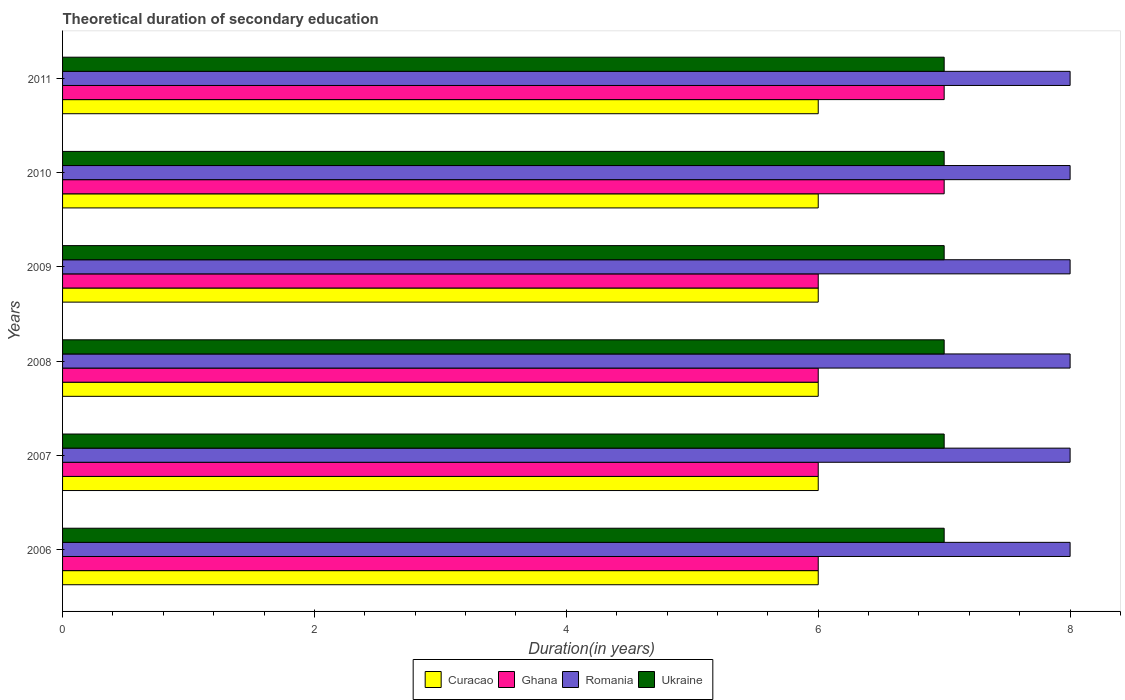How many different coloured bars are there?
Provide a succinct answer. 4. How many bars are there on the 1st tick from the bottom?
Your answer should be very brief. 4. What is the label of the 3rd group of bars from the top?
Your answer should be compact. 2009. In how many cases, is the number of bars for a given year not equal to the number of legend labels?
Provide a succinct answer. 0. What is the total theoretical duration of secondary education in Ukraine in 2008?
Make the answer very short. 7. Across all years, what is the maximum total theoretical duration of secondary education in Ukraine?
Ensure brevity in your answer.  7. Across all years, what is the minimum total theoretical duration of secondary education in Ghana?
Offer a very short reply. 6. What is the total total theoretical duration of secondary education in Ukraine in the graph?
Provide a short and direct response. 42. What is the difference between the total theoretical duration of secondary education in Ghana in 2009 and that in 2011?
Make the answer very short. -1. What is the difference between the total theoretical duration of secondary education in Curacao in 2010 and the total theoretical duration of secondary education in Romania in 2006?
Provide a succinct answer. -2. In how many years, is the total theoretical duration of secondary education in Ghana greater than 2.4 years?
Provide a short and direct response. 6. What is the ratio of the total theoretical duration of secondary education in Ukraine in 2007 to that in 2009?
Give a very brief answer. 1. Is the total theoretical duration of secondary education in Ghana in 2007 less than that in 2008?
Your response must be concise. No. What is the difference between the highest and the second highest total theoretical duration of secondary education in Ghana?
Offer a terse response. 0. What is the difference between the highest and the lowest total theoretical duration of secondary education in Ghana?
Your response must be concise. 1. Is the sum of the total theoretical duration of secondary education in Curacao in 2007 and 2010 greater than the maximum total theoretical duration of secondary education in Ghana across all years?
Keep it short and to the point. Yes. Is it the case that in every year, the sum of the total theoretical duration of secondary education in Ghana and total theoretical duration of secondary education in Ukraine is greater than the sum of total theoretical duration of secondary education in Romania and total theoretical duration of secondary education in Curacao?
Ensure brevity in your answer.  Yes. What does the 2nd bar from the top in 2007 represents?
Offer a very short reply. Romania. What does the 4th bar from the bottom in 2010 represents?
Provide a short and direct response. Ukraine. Is it the case that in every year, the sum of the total theoretical duration of secondary education in Curacao and total theoretical duration of secondary education in Romania is greater than the total theoretical duration of secondary education in Ghana?
Your answer should be very brief. Yes. Are all the bars in the graph horizontal?
Provide a succinct answer. Yes. How many years are there in the graph?
Offer a very short reply. 6. Does the graph contain any zero values?
Offer a very short reply. No. How many legend labels are there?
Your answer should be very brief. 4. How are the legend labels stacked?
Your answer should be compact. Horizontal. What is the title of the graph?
Your answer should be compact. Theoretical duration of secondary education. Does "Bahamas" appear as one of the legend labels in the graph?
Make the answer very short. No. What is the label or title of the X-axis?
Ensure brevity in your answer.  Duration(in years). What is the label or title of the Y-axis?
Give a very brief answer. Years. What is the Duration(in years) of Romania in 2006?
Give a very brief answer. 8. What is the Duration(in years) in Curacao in 2007?
Your answer should be very brief. 6. What is the Duration(in years) in Ghana in 2007?
Make the answer very short. 6. What is the Duration(in years) in Ghana in 2008?
Keep it short and to the point. 6. What is the Duration(in years) of Ukraine in 2008?
Your answer should be compact. 7. What is the Duration(in years) of Curacao in 2009?
Offer a very short reply. 6. What is the Duration(in years) in Romania in 2009?
Give a very brief answer. 8. What is the Duration(in years) in Romania in 2010?
Provide a succinct answer. 8. What is the Duration(in years) of Ukraine in 2010?
Give a very brief answer. 7. What is the Duration(in years) of Ghana in 2011?
Make the answer very short. 7. What is the Duration(in years) in Ukraine in 2011?
Give a very brief answer. 7. Across all years, what is the maximum Duration(in years) of Curacao?
Keep it short and to the point. 6. Across all years, what is the maximum Duration(in years) in Ghana?
Your answer should be compact. 7. Across all years, what is the minimum Duration(in years) of Curacao?
Make the answer very short. 6. Across all years, what is the minimum Duration(in years) in Romania?
Your answer should be compact. 8. What is the total Duration(in years) in Curacao in the graph?
Provide a short and direct response. 36. What is the total Duration(in years) of Ghana in the graph?
Provide a short and direct response. 38. What is the total Duration(in years) of Romania in the graph?
Provide a succinct answer. 48. What is the total Duration(in years) in Ukraine in the graph?
Your answer should be compact. 42. What is the difference between the Duration(in years) in Curacao in 2006 and that in 2007?
Offer a very short reply. 0. What is the difference between the Duration(in years) in Ghana in 2006 and that in 2007?
Your answer should be compact. 0. What is the difference between the Duration(in years) in Curacao in 2006 and that in 2008?
Give a very brief answer. 0. What is the difference between the Duration(in years) of Ghana in 2006 and that in 2008?
Make the answer very short. 0. What is the difference between the Duration(in years) in Romania in 2006 and that in 2008?
Offer a very short reply. 0. What is the difference between the Duration(in years) in Ukraine in 2006 and that in 2008?
Provide a short and direct response. 0. What is the difference between the Duration(in years) in Curacao in 2006 and that in 2009?
Give a very brief answer. 0. What is the difference between the Duration(in years) in Ghana in 2006 and that in 2009?
Offer a very short reply. 0. What is the difference between the Duration(in years) in Romania in 2006 and that in 2009?
Ensure brevity in your answer.  0. What is the difference between the Duration(in years) in Ukraine in 2006 and that in 2009?
Make the answer very short. 0. What is the difference between the Duration(in years) of Curacao in 2006 and that in 2010?
Give a very brief answer. 0. What is the difference between the Duration(in years) in Romania in 2006 and that in 2010?
Your answer should be compact. 0. What is the difference between the Duration(in years) in Curacao in 2007 and that in 2008?
Keep it short and to the point. 0. What is the difference between the Duration(in years) in Ghana in 2007 and that in 2008?
Ensure brevity in your answer.  0. What is the difference between the Duration(in years) of Ukraine in 2007 and that in 2008?
Your answer should be compact. 0. What is the difference between the Duration(in years) of Curacao in 2007 and that in 2009?
Provide a short and direct response. 0. What is the difference between the Duration(in years) of Curacao in 2007 and that in 2010?
Your answer should be compact. 0. What is the difference between the Duration(in years) in Romania in 2007 and that in 2010?
Give a very brief answer. 0. What is the difference between the Duration(in years) in Ghana in 2007 and that in 2011?
Provide a succinct answer. -1. What is the difference between the Duration(in years) of Ukraine in 2007 and that in 2011?
Offer a very short reply. 0. What is the difference between the Duration(in years) in Curacao in 2008 and that in 2009?
Your answer should be very brief. 0. What is the difference between the Duration(in years) in Ukraine in 2008 and that in 2009?
Offer a very short reply. 0. What is the difference between the Duration(in years) in Curacao in 2008 and that in 2010?
Offer a terse response. 0. What is the difference between the Duration(in years) of Ukraine in 2008 and that in 2010?
Your response must be concise. 0. What is the difference between the Duration(in years) in Ghana in 2009 and that in 2010?
Offer a very short reply. -1. What is the difference between the Duration(in years) of Romania in 2009 and that in 2010?
Your answer should be compact. 0. What is the difference between the Duration(in years) in Ghana in 2009 and that in 2011?
Give a very brief answer. -1. What is the difference between the Duration(in years) in Ukraine in 2009 and that in 2011?
Offer a terse response. 0. What is the difference between the Duration(in years) in Ghana in 2010 and that in 2011?
Provide a succinct answer. 0. What is the difference between the Duration(in years) of Curacao in 2006 and the Duration(in years) of Ukraine in 2007?
Provide a succinct answer. -1. What is the difference between the Duration(in years) of Ghana in 2006 and the Duration(in years) of Ukraine in 2007?
Provide a short and direct response. -1. What is the difference between the Duration(in years) in Curacao in 2006 and the Duration(in years) in Ukraine in 2008?
Provide a succinct answer. -1. What is the difference between the Duration(in years) in Ghana in 2006 and the Duration(in years) in Ukraine in 2008?
Ensure brevity in your answer.  -1. What is the difference between the Duration(in years) of Romania in 2006 and the Duration(in years) of Ukraine in 2008?
Give a very brief answer. 1. What is the difference between the Duration(in years) of Curacao in 2006 and the Duration(in years) of Romania in 2009?
Give a very brief answer. -2. What is the difference between the Duration(in years) of Romania in 2006 and the Duration(in years) of Ukraine in 2009?
Offer a terse response. 1. What is the difference between the Duration(in years) of Curacao in 2006 and the Duration(in years) of Ghana in 2010?
Your answer should be very brief. -1. What is the difference between the Duration(in years) of Curacao in 2006 and the Duration(in years) of Ukraine in 2010?
Provide a succinct answer. -1. What is the difference between the Duration(in years) of Ghana in 2006 and the Duration(in years) of Ukraine in 2010?
Your response must be concise. -1. What is the difference between the Duration(in years) in Curacao in 2006 and the Duration(in years) in Romania in 2011?
Your answer should be very brief. -2. What is the difference between the Duration(in years) of Romania in 2006 and the Duration(in years) of Ukraine in 2011?
Keep it short and to the point. 1. What is the difference between the Duration(in years) in Curacao in 2007 and the Duration(in years) in Romania in 2008?
Offer a terse response. -2. What is the difference between the Duration(in years) in Ghana in 2007 and the Duration(in years) in Ukraine in 2008?
Give a very brief answer. -1. What is the difference between the Duration(in years) in Romania in 2007 and the Duration(in years) in Ukraine in 2008?
Give a very brief answer. 1. What is the difference between the Duration(in years) in Curacao in 2007 and the Duration(in years) in Ghana in 2009?
Make the answer very short. 0. What is the difference between the Duration(in years) in Curacao in 2007 and the Duration(in years) in Ukraine in 2009?
Provide a short and direct response. -1. What is the difference between the Duration(in years) in Ghana in 2007 and the Duration(in years) in Romania in 2009?
Give a very brief answer. -2. What is the difference between the Duration(in years) of Ghana in 2007 and the Duration(in years) of Ukraine in 2009?
Your answer should be compact. -1. What is the difference between the Duration(in years) of Curacao in 2007 and the Duration(in years) of Ghana in 2010?
Your response must be concise. -1. What is the difference between the Duration(in years) of Curacao in 2007 and the Duration(in years) of Romania in 2010?
Provide a succinct answer. -2. What is the difference between the Duration(in years) in Ghana in 2007 and the Duration(in years) in Ukraine in 2010?
Make the answer very short. -1. What is the difference between the Duration(in years) of Romania in 2007 and the Duration(in years) of Ukraine in 2010?
Provide a succinct answer. 1. What is the difference between the Duration(in years) of Curacao in 2007 and the Duration(in years) of Ghana in 2011?
Keep it short and to the point. -1. What is the difference between the Duration(in years) in Ghana in 2007 and the Duration(in years) in Ukraine in 2011?
Make the answer very short. -1. What is the difference between the Duration(in years) of Romania in 2007 and the Duration(in years) of Ukraine in 2011?
Keep it short and to the point. 1. What is the difference between the Duration(in years) of Curacao in 2008 and the Duration(in years) of Romania in 2009?
Provide a short and direct response. -2. What is the difference between the Duration(in years) of Ghana in 2008 and the Duration(in years) of Romania in 2009?
Provide a short and direct response. -2. What is the difference between the Duration(in years) in Romania in 2008 and the Duration(in years) in Ukraine in 2009?
Your answer should be very brief. 1. What is the difference between the Duration(in years) of Curacao in 2008 and the Duration(in years) of Romania in 2010?
Your answer should be compact. -2. What is the difference between the Duration(in years) of Curacao in 2008 and the Duration(in years) of Ukraine in 2010?
Provide a short and direct response. -1. What is the difference between the Duration(in years) in Ghana in 2008 and the Duration(in years) in Ukraine in 2010?
Keep it short and to the point. -1. What is the difference between the Duration(in years) in Curacao in 2008 and the Duration(in years) in Romania in 2011?
Offer a very short reply. -2. What is the difference between the Duration(in years) of Ghana in 2008 and the Duration(in years) of Romania in 2011?
Your response must be concise. -2. What is the difference between the Duration(in years) in Romania in 2008 and the Duration(in years) in Ukraine in 2011?
Give a very brief answer. 1. What is the difference between the Duration(in years) of Curacao in 2009 and the Duration(in years) of Ghana in 2010?
Provide a succinct answer. -1. What is the difference between the Duration(in years) in Ghana in 2009 and the Duration(in years) in Romania in 2010?
Your answer should be compact. -2. What is the difference between the Duration(in years) in Ghana in 2009 and the Duration(in years) in Ukraine in 2010?
Offer a very short reply. -1. What is the difference between the Duration(in years) of Romania in 2009 and the Duration(in years) of Ukraine in 2010?
Provide a succinct answer. 1. What is the difference between the Duration(in years) of Curacao in 2009 and the Duration(in years) of Ukraine in 2011?
Your answer should be very brief. -1. What is the difference between the Duration(in years) in Ghana in 2009 and the Duration(in years) in Ukraine in 2011?
Offer a very short reply. -1. What is the difference between the Duration(in years) of Ghana in 2010 and the Duration(in years) of Ukraine in 2011?
Ensure brevity in your answer.  0. What is the average Duration(in years) of Curacao per year?
Your answer should be compact. 6. What is the average Duration(in years) in Ghana per year?
Your response must be concise. 6.33. In the year 2006, what is the difference between the Duration(in years) of Curacao and Duration(in years) of Ghana?
Your answer should be very brief. 0. In the year 2006, what is the difference between the Duration(in years) of Ghana and Duration(in years) of Romania?
Provide a succinct answer. -2. In the year 2006, what is the difference between the Duration(in years) in Romania and Duration(in years) in Ukraine?
Offer a very short reply. 1. In the year 2007, what is the difference between the Duration(in years) in Curacao and Duration(in years) in Romania?
Offer a terse response. -2. In the year 2007, what is the difference between the Duration(in years) in Curacao and Duration(in years) in Ukraine?
Ensure brevity in your answer.  -1. In the year 2007, what is the difference between the Duration(in years) in Ghana and Duration(in years) in Romania?
Provide a succinct answer. -2. In the year 2007, what is the difference between the Duration(in years) in Ghana and Duration(in years) in Ukraine?
Offer a very short reply. -1. In the year 2007, what is the difference between the Duration(in years) in Romania and Duration(in years) in Ukraine?
Keep it short and to the point. 1. In the year 2008, what is the difference between the Duration(in years) in Curacao and Duration(in years) in Romania?
Your answer should be very brief. -2. In the year 2008, what is the difference between the Duration(in years) in Curacao and Duration(in years) in Ukraine?
Your answer should be compact. -1. In the year 2008, what is the difference between the Duration(in years) of Ghana and Duration(in years) of Romania?
Offer a very short reply. -2. In the year 2008, what is the difference between the Duration(in years) of Ghana and Duration(in years) of Ukraine?
Keep it short and to the point. -1. In the year 2008, what is the difference between the Duration(in years) in Romania and Duration(in years) in Ukraine?
Keep it short and to the point. 1. In the year 2009, what is the difference between the Duration(in years) in Romania and Duration(in years) in Ukraine?
Your answer should be compact. 1. In the year 2010, what is the difference between the Duration(in years) of Curacao and Duration(in years) of Ghana?
Give a very brief answer. -1. In the year 2010, what is the difference between the Duration(in years) of Ghana and Duration(in years) of Ukraine?
Make the answer very short. 0. In the year 2010, what is the difference between the Duration(in years) in Romania and Duration(in years) in Ukraine?
Make the answer very short. 1. In the year 2011, what is the difference between the Duration(in years) of Curacao and Duration(in years) of Ukraine?
Provide a succinct answer. -1. In the year 2011, what is the difference between the Duration(in years) in Ghana and Duration(in years) in Romania?
Give a very brief answer. -1. In the year 2011, what is the difference between the Duration(in years) in Ghana and Duration(in years) in Ukraine?
Your answer should be compact. 0. In the year 2011, what is the difference between the Duration(in years) in Romania and Duration(in years) in Ukraine?
Your answer should be very brief. 1. What is the ratio of the Duration(in years) in Ghana in 2006 to that in 2007?
Offer a very short reply. 1. What is the ratio of the Duration(in years) in Romania in 2006 to that in 2007?
Offer a terse response. 1. What is the ratio of the Duration(in years) in Ukraine in 2006 to that in 2007?
Give a very brief answer. 1. What is the ratio of the Duration(in years) of Ghana in 2006 to that in 2008?
Your answer should be compact. 1. What is the ratio of the Duration(in years) of Ghana in 2006 to that in 2009?
Offer a very short reply. 1. What is the ratio of the Duration(in years) in Ghana in 2006 to that in 2010?
Keep it short and to the point. 0.86. What is the ratio of the Duration(in years) of Ukraine in 2006 to that in 2010?
Offer a terse response. 1. What is the ratio of the Duration(in years) of Curacao in 2006 to that in 2011?
Ensure brevity in your answer.  1. What is the ratio of the Duration(in years) in Romania in 2007 to that in 2008?
Keep it short and to the point. 1. What is the ratio of the Duration(in years) in Curacao in 2007 to that in 2009?
Your response must be concise. 1. What is the ratio of the Duration(in years) of Ukraine in 2007 to that in 2009?
Your response must be concise. 1. What is the ratio of the Duration(in years) of Romania in 2007 to that in 2010?
Your response must be concise. 1. What is the ratio of the Duration(in years) of Ukraine in 2007 to that in 2010?
Ensure brevity in your answer.  1. What is the ratio of the Duration(in years) of Curacao in 2007 to that in 2011?
Provide a short and direct response. 1. What is the ratio of the Duration(in years) in Romania in 2007 to that in 2011?
Offer a very short reply. 1. What is the ratio of the Duration(in years) of Ukraine in 2007 to that in 2011?
Provide a short and direct response. 1. What is the ratio of the Duration(in years) of Romania in 2008 to that in 2009?
Offer a very short reply. 1. What is the ratio of the Duration(in years) in Curacao in 2008 to that in 2010?
Keep it short and to the point. 1. What is the ratio of the Duration(in years) of Ghana in 2008 to that in 2010?
Provide a short and direct response. 0.86. What is the ratio of the Duration(in years) of Romania in 2008 to that in 2010?
Your answer should be very brief. 1. What is the ratio of the Duration(in years) in Ukraine in 2008 to that in 2010?
Offer a very short reply. 1. What is the ratio of the Duration(in years) of Curacao in 2009 to that in 2010?
Make the answer very short. 1. What is the ratio of the Duration(in years) in Ghana in 2009 to that in 2011?
Offer a very short reply. 0.86. What is the ratio of the Duration(in years) of Ukraine in 2009 to that in 2011?
Your answer should be very brief. 1. What is the ratio of the Duration(in years) of Curacao in 2010 to that in 2011?
Your response must be concise. 1. What is the ratio of the Duration(in years) in Ghana in 2010 to that in 2011?
Give a very brief answer. 1. What is the ratio of the Duration(in years) of Romania in 2010 to that in 2011?
Your answer should be very brief. 1. What is the ratio of the Duration(in years) of Ukraine in 2010 to that in 2011?
Offer a very short reply. 1. What is the difference between the highest and the second highest Duration(in years) of Curacao?
Keep it short and to the point. 0. What is the difference between the highest and the second highest Duration(in years) of Ukraine?
Offer a terse response. 0. 